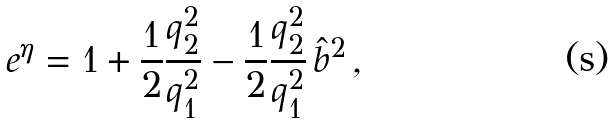Convert formula to latex. <formula><loc_0><loc_0><loc_500><loc_500>e ^ { \eta } = 1 + \frac { 1 } { 2 } \frac { q _ { 2 } ^ { 2 } } { q _ { 1 } ^ { 2 } } - \frac { 1 } { 2 } \frac { q _ { 2 } ^ { 2 } } { q _ { 1 } ^ { 2 } } \, \hat { b } ^ { 2 } \, ,</formula> 